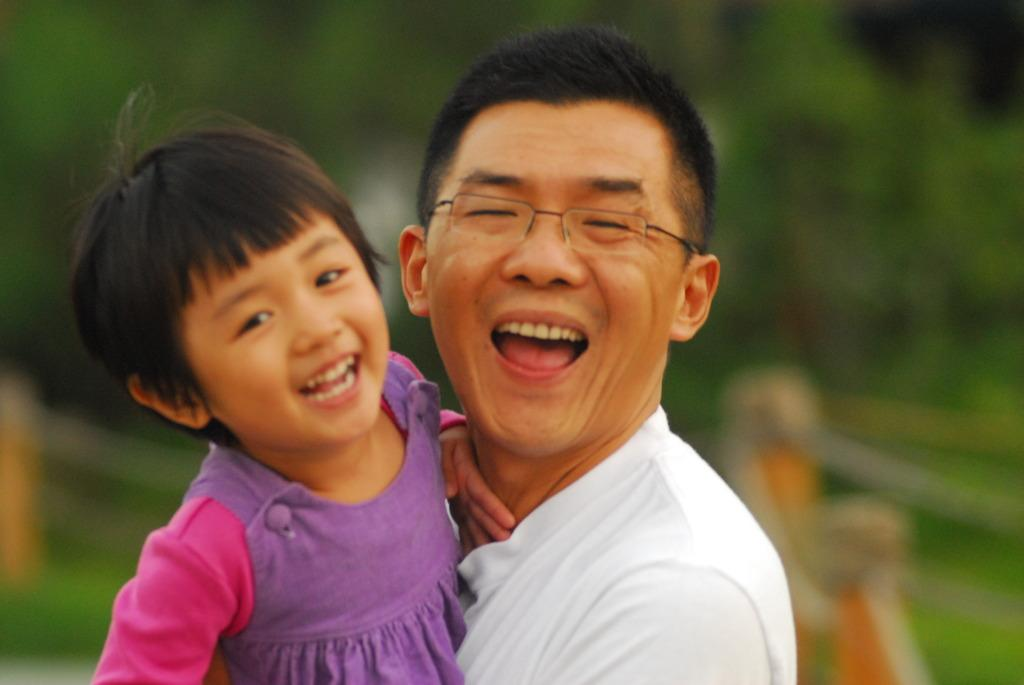How many people are in the image? There are persons in the image, but the exact number is not specified. What is the facial expression of the persons in the image? The persons in the image are smiling. Can you describe the background of the image? The background of the image is blurry. What type of cover is being used in the competition shown in the image? There is no competition or cover present in the image; it features persons smiling with a blurry background. 